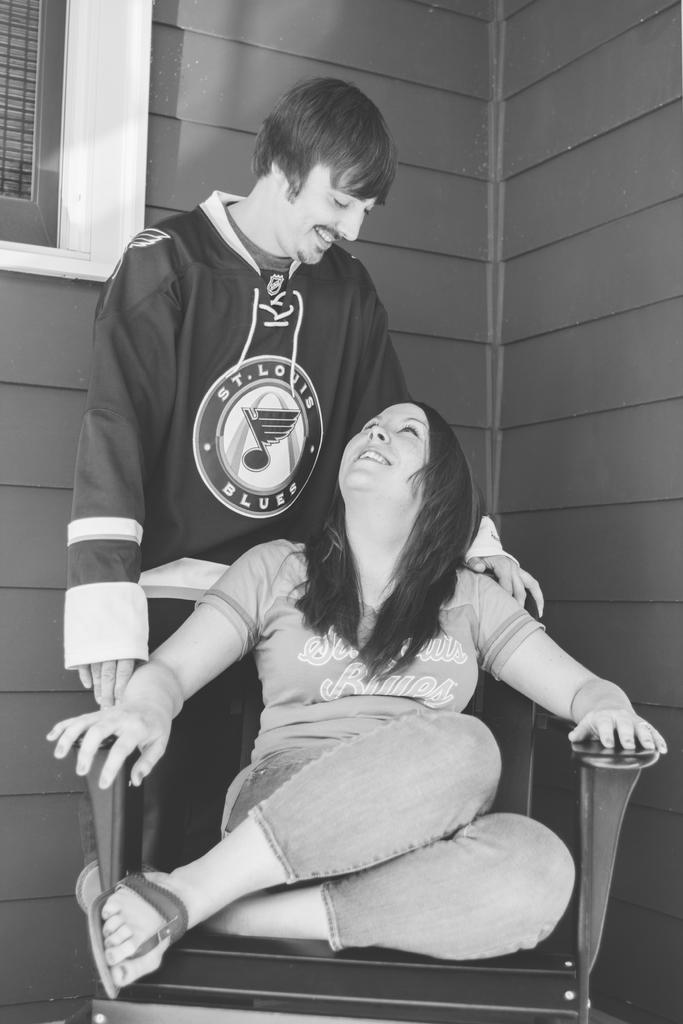<image>
Share a concise interpretation of the image provided. A guy in a St. Louis Blues hoodie and a a girl in a chair. 